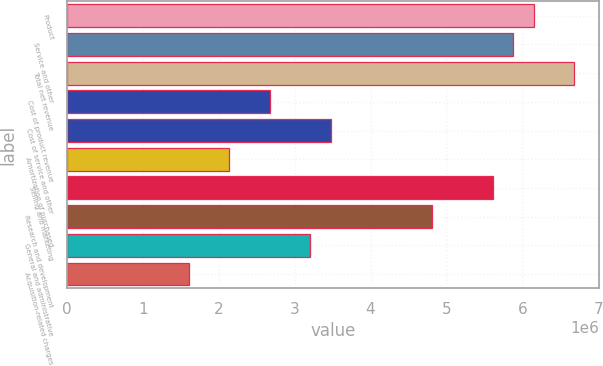Convert chart to OTSL. <chart><loc_0><loc_0><loc_500><loc_500><bar_chart><fcel>Product<fcel>Service and other<fcel>Total net revenue<fcel>Cost of product revenue<fcel>Cost of service and other<fcel>Amortization of purchased<fcel>Selling and marketing<fcel>Research and development<fcel>General and administrative<fcel>Acquisition-related charges<nl><fcel>6.14778e+06<fcel>5.88048e+06<fcel>6.68237e+06<fcel>2.67295e+06<fcel>3.47483e+06<fcel>2.13836e+06<fcel>5.61319e+06<fcel>4.8113e+06<fcel>3.20754e+06<fcel>1.60377e+06<nl></chart> 